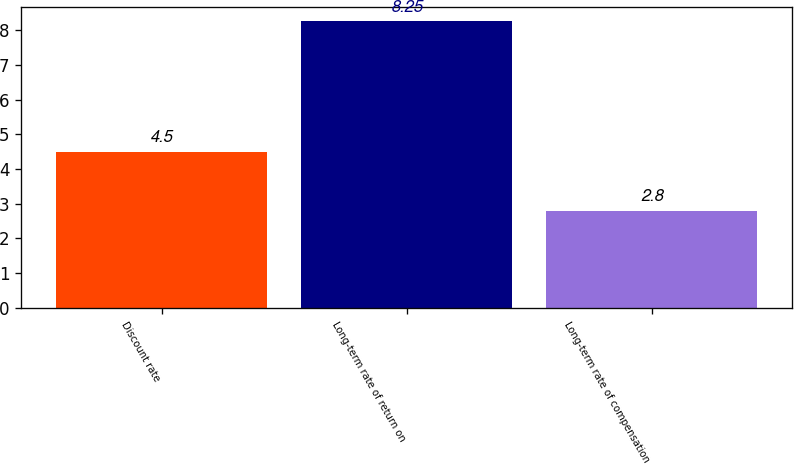Convert chart. <chart><loc_0><loc_0><loc_500><loc_500><bar_chart><fcel>Discount rate<fcel>Long-term rate of return on<fcel>Long-term rate of compensation<nl><fcel>4.5<fcel>8.25<fcel>2.8<nl></chart> 